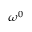<formula> <loc_0><loc_0><loc_500><loc_500>\omega ^ { 0 }</formula> 